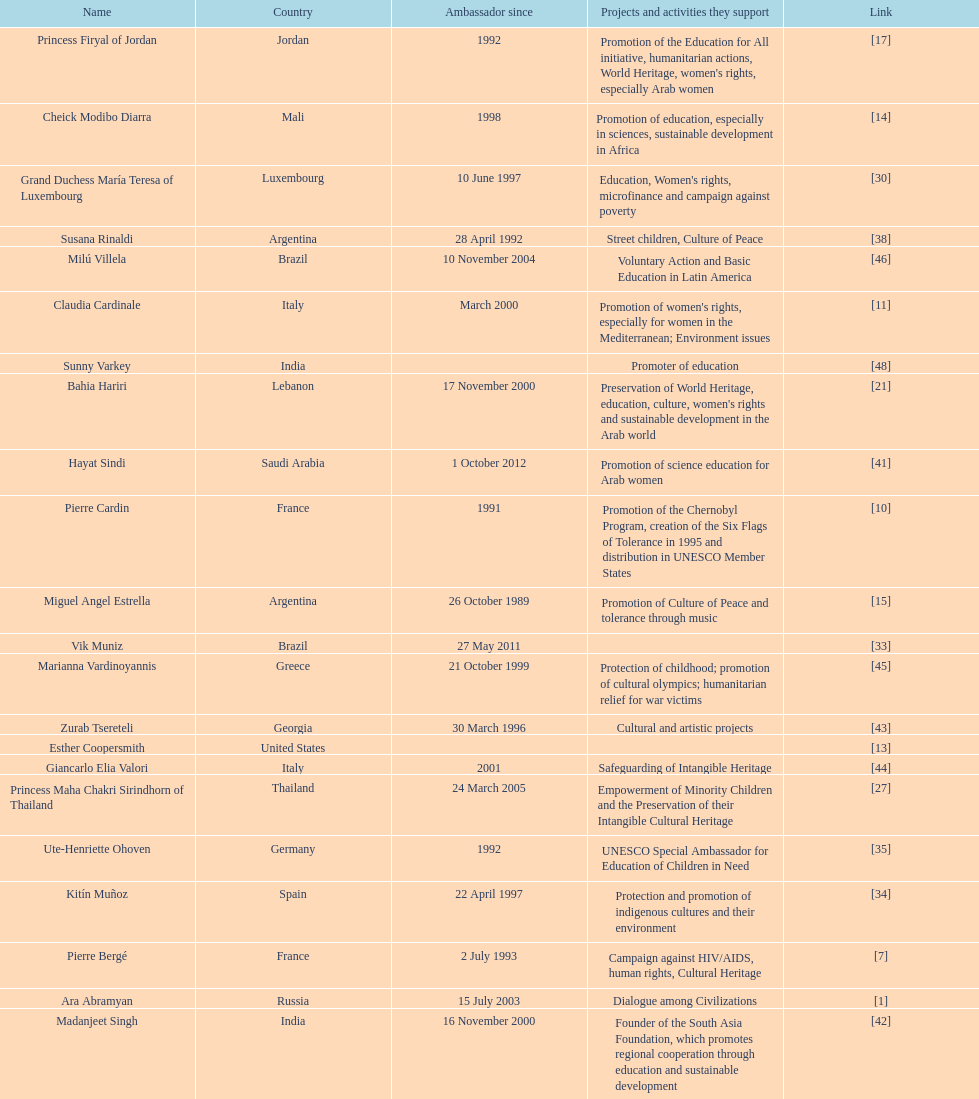Which unesco goodwill ambassador is most known for the promotion of the chernobyl program? Pierre Cardin. 